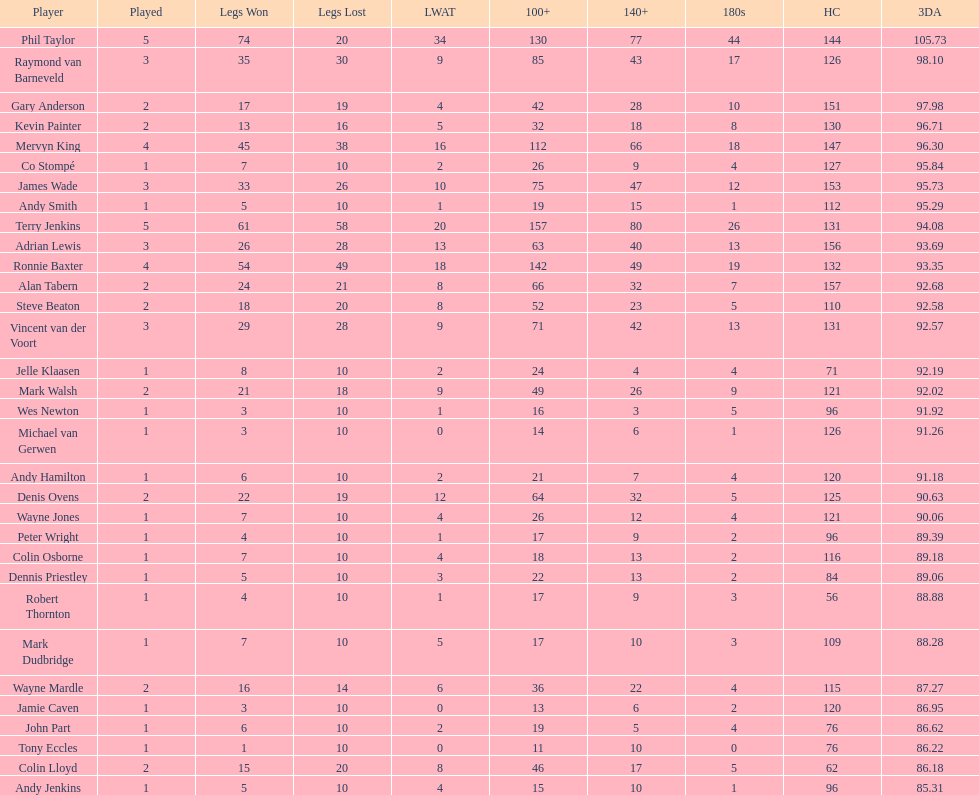Was the 3-dart average for andy smith or kevin painter 9 Kevin Painter. 